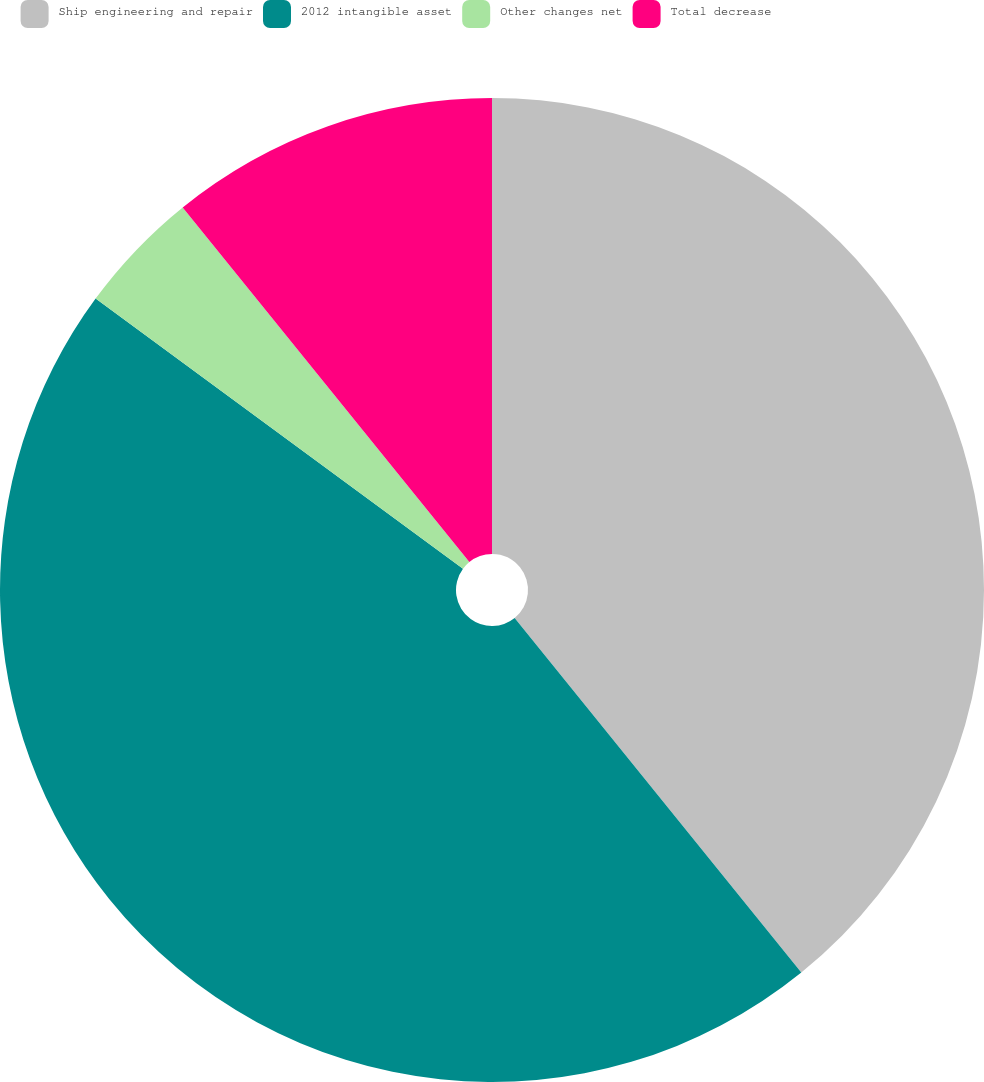Convert chart to OTSL. <chart><loc_0><loc_0><loc_500><loc_500><pie_chart><fcel>Ship engineering and repair<fcel>2012 intangible asset<fcel>Other changes net<fcel>Total decrease<nl><fcel>39.18%<fcel>45.91%<fcel>4.09%<fcel>10.82%<nl></chart> 